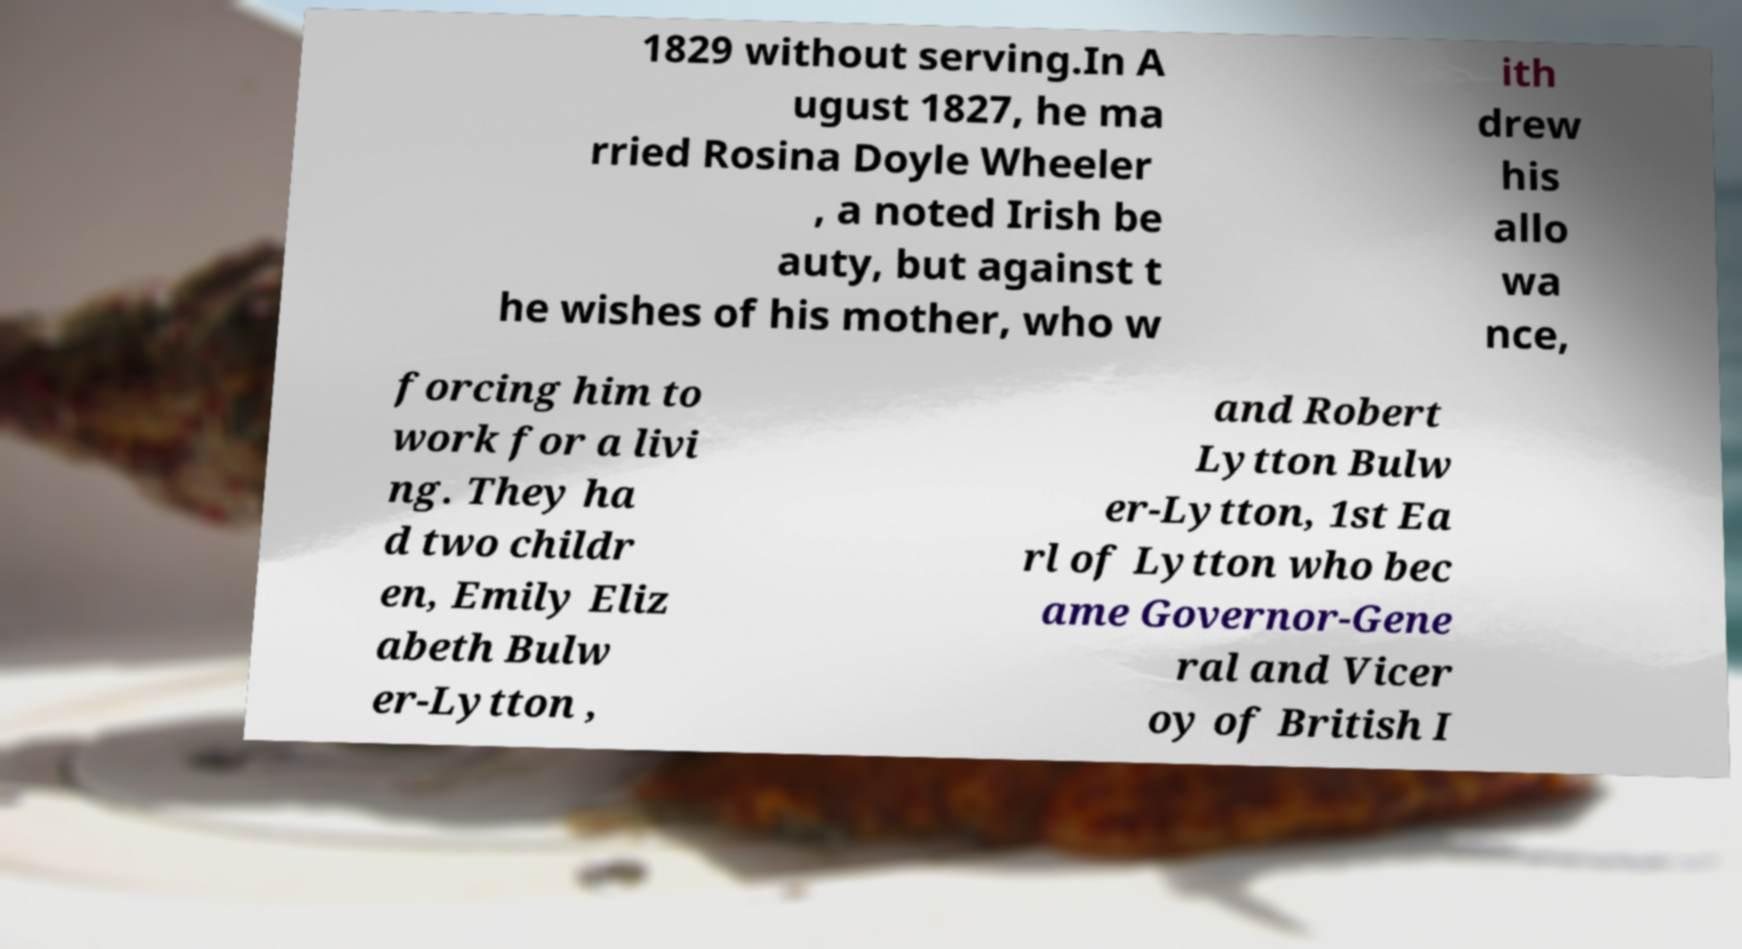There's text embedded in this image that I need extracted. Can you transcribe it verbatim? 1829 without serving.In A ugust 1827, he ma rried Rosina Doyle Wheeler , a noted Irish be auty, but against t he wishes of his mother, who w ith drew his allo wa nce, forcing him to work for a livi ng. They ha d two childr en, Emily Eliz abeth Bulw er-Lytton , and Robert Lytton Bulw er-Lytton, 1st Ea rl of Lytton who bec ame Governor-Gene ral and Vicer oy of British I 